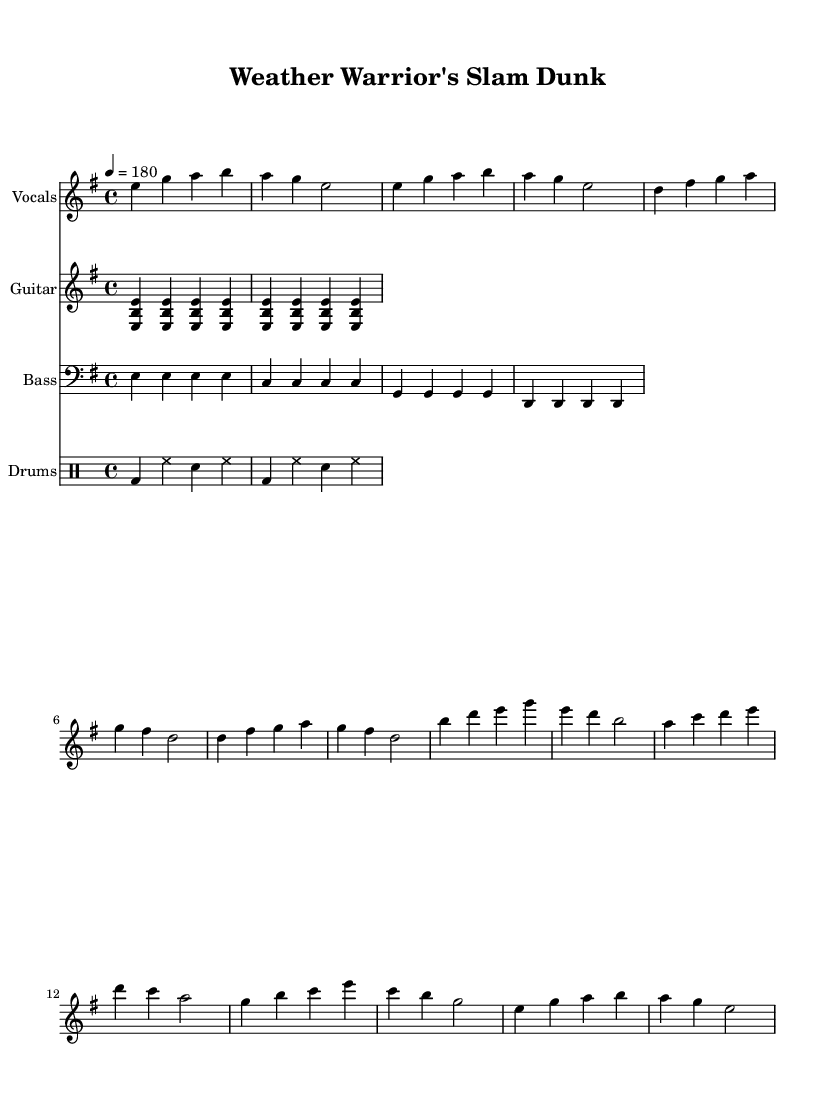What is the key signature of this music? The key signature is indicated by the number of sharps or flats following the clef. In this case, there are no sharps or flats shown in the key signature, meaning it is in E minor.
Answer: E minor What is the time signature? The time signature is given at the beginning of the piece, indicating how many beats are in each measure. Here, it is shown as 4/4.
Answer: 4/4 What is the tempo marking? The tempo marking is typically given in beats per minute, located at the beginning. In this score, it is marked as "4 = 180", indicating the speed of the music.
Answer: 180 How many measures does the chorus contain? By counting the measures in the chorus section of the vocal part, there are a total of 8 measures in the chorus.
Answer: 8 What instruments are included in the score? The instruments are indicated at the beginning of each staff; they include "Vocals," "Guitar," "Bass," and "Drums."
Answer: Vocals, Guitar, Bass, Drums What type of chords is primarily used in the guitar part? The guitar part uses power chords, characterized by the notes played together specifically in the format of root and fifth. This is evident from the structure of the guitar riff.
Answer: Power chords Which theme is present in the lyrics of the song? The lyrics reflect the expertise and appreciation of meteorologists, celebrating them as unsung heroes in sports contexts, indicated by the focus on forecasting and weather conditions.
Answer: Meteorologists 